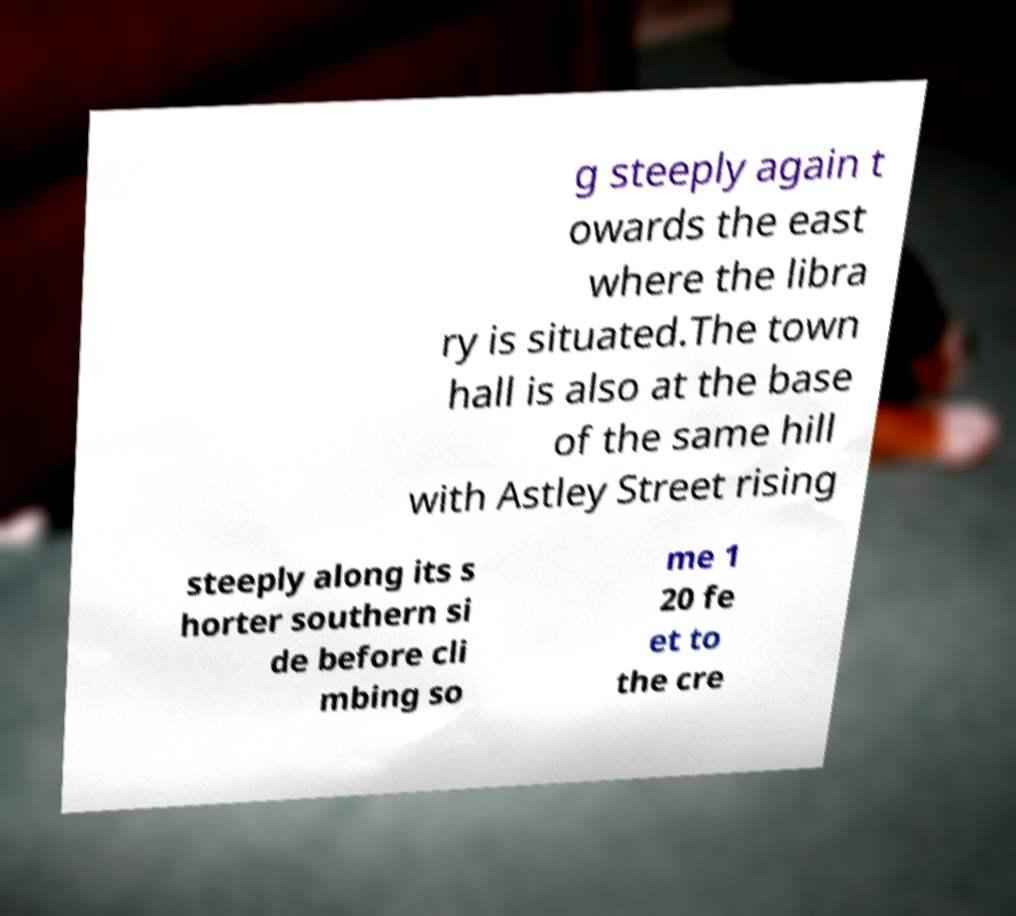Please read and relay the text visible in this image. What does it say? g steeply again t owards the east where the libra ry is situated.The town hall is also at the base of the same hill with Astley Street rising steeply along its s horter southern si de before cli mbing so me 1 20 fe et to the cre 